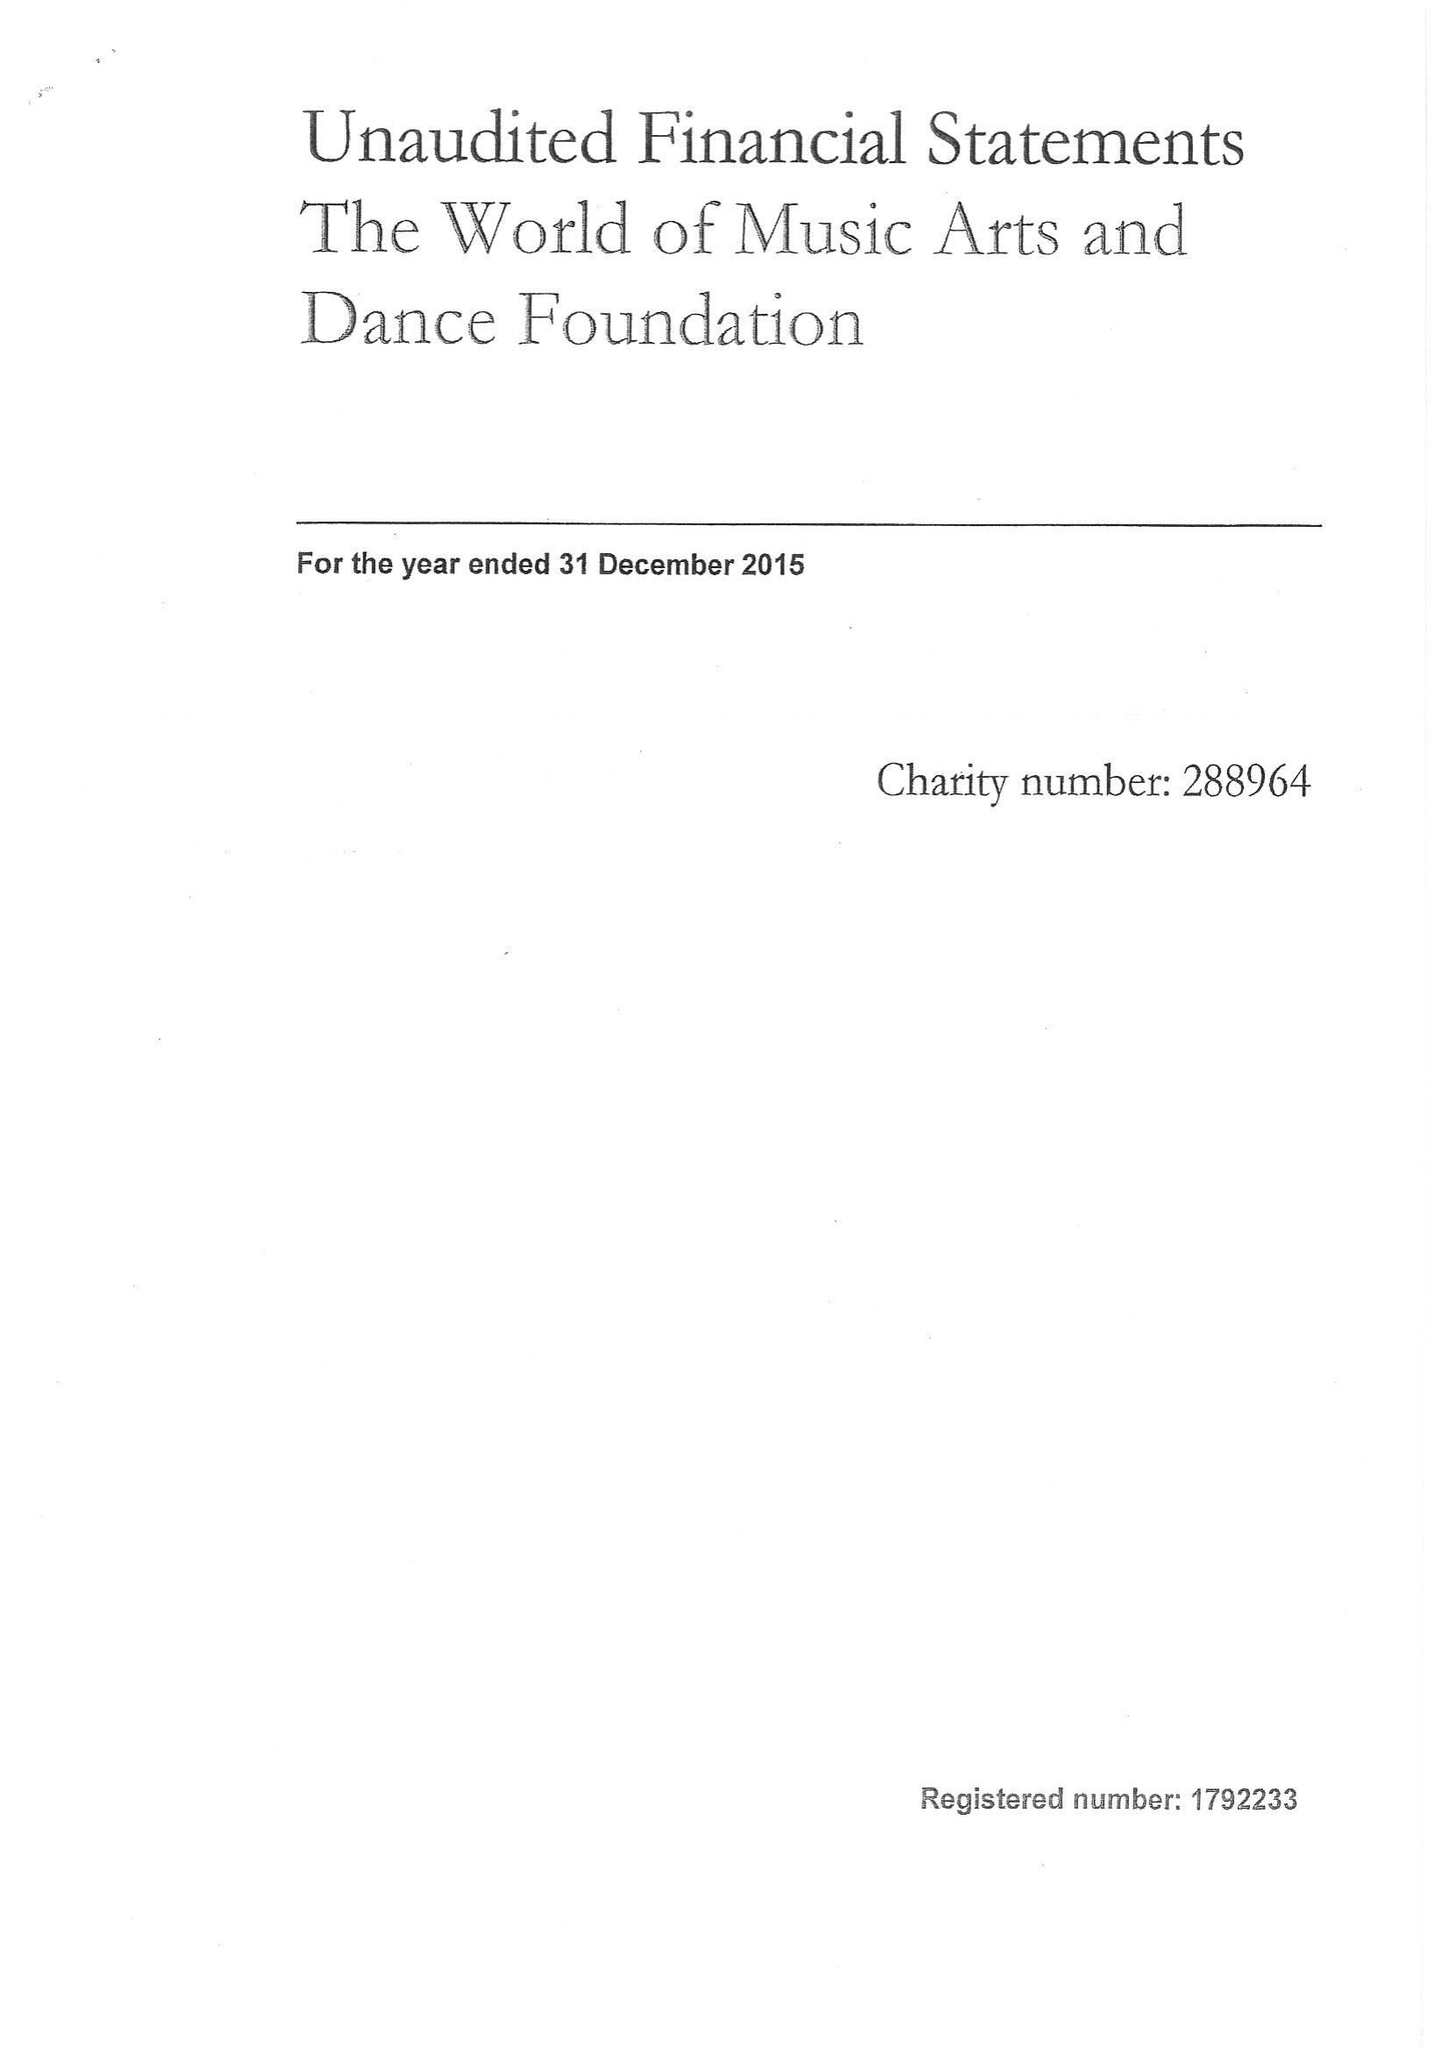What is the value for the report_date?
Answer the question using a single word or phrase. 2015-12-31 